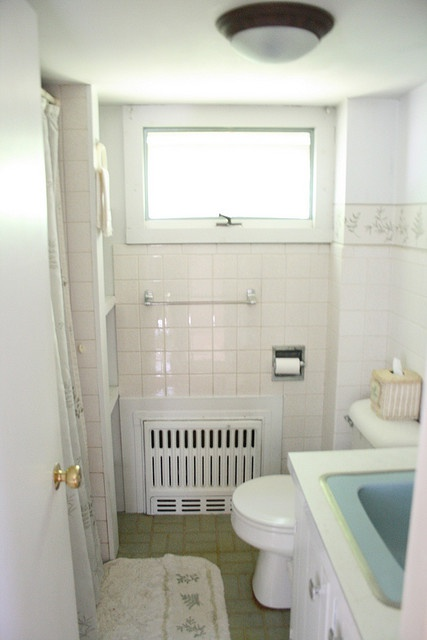Describe the objects in this image and their specific colors. I can see sink in darkgray, gray, and beige tones and toilet in darkgray, lightgray, and gray tones in this image. 